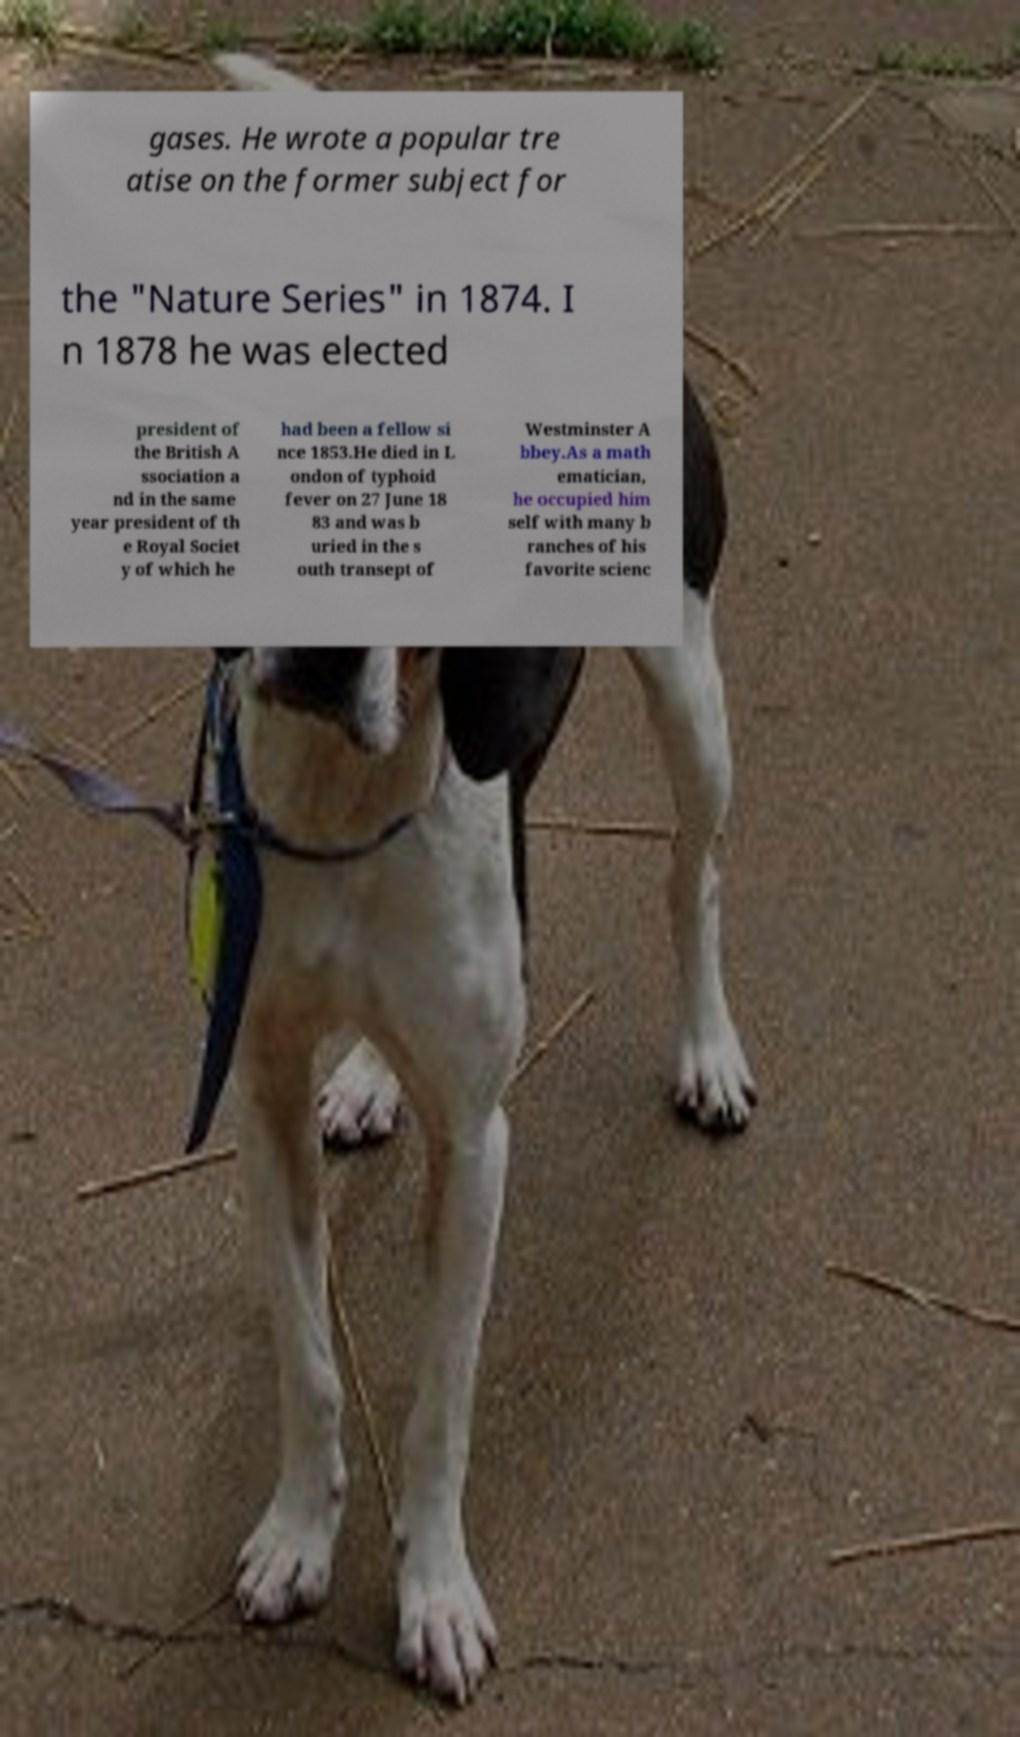What messages or text are displayed in this image? I need them in a readable, typed format. gases. He wrote a popular tre atise on the former subject for the "Nature Series" in 1874. I n 1878 he was elected president of the British A ssociation a nd in the same year president of th e Royal Societ y of which he had been a fellow si nce 1853.He died in L ondon of typhoid fever on 27 June 18 83 and was b uried in the s outh transept of Westminster A bbey.As a math ematician, he occupied him self with many b ranches of his favorite scienc 